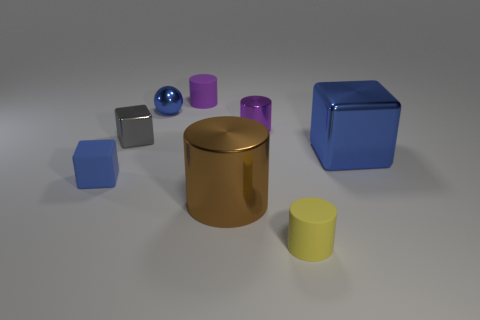What number of small things have the same color as the big cube?
Give a very brief answer. 2. The blue thing behind the small metallic thing left of the tiny blue metallic ball is what shape?
Offer a very short reply. Sphere. How many yellow things are rubber objects or big metal cylinders?
Your answer should be very brief. 1. The matte cube is what color?
Offer a very short reply. Blue. Do the purple matte object and the purple shiny object have the same size?
Give a very brief answer. Yes. Is there any other thing that is the same shape as the tiny blue metallic thing?
Provide a succinct answer. No. Is the material of the large brown cylinder the same as the blue thing that is behind the big shiny block?
Your answer should be compact. Yes. Is the color of the rubber cylinder that is behind the large cube the same as the tiny metallic cylinder?
Provide a short and direct response. Yes. What number of cylinders are in front of the big blue metallic thing and behind the shiny sphere?
Give a very brief answer. 0. How many other objects are the same material as the big block?
Your answer should be very brief. 4. 